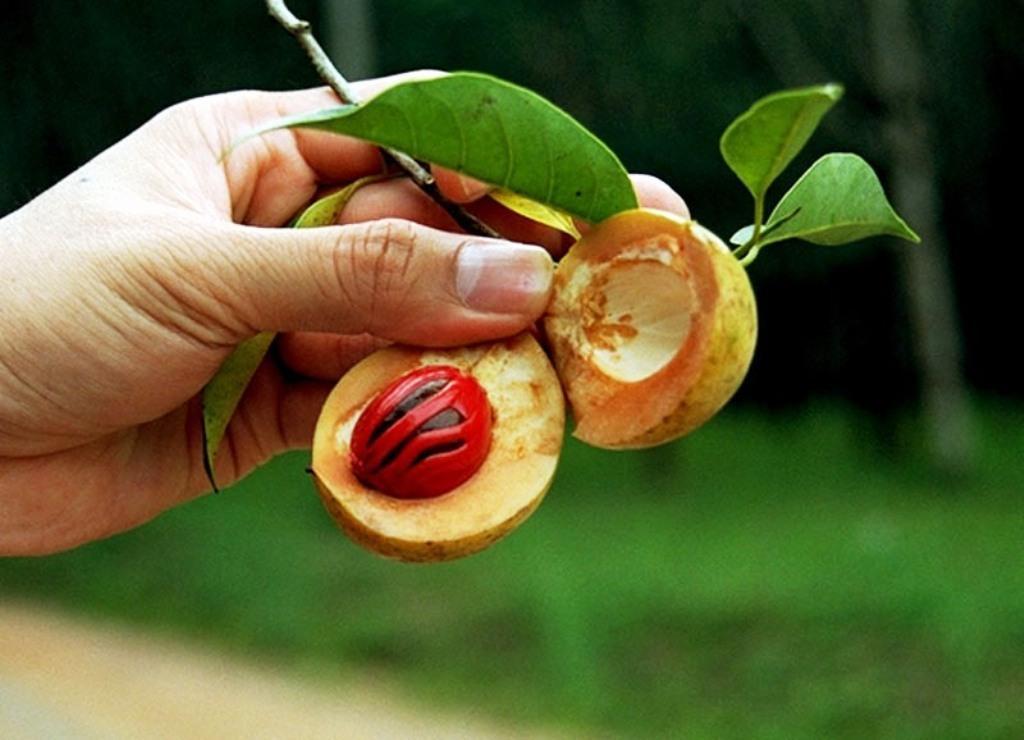Can you describe this image briefly? In the center of the image we can see one human hand holding one fruit and leaves. In the fruit, we can see one seed, which is in red and brown color. In the background we can see the grass etc. 